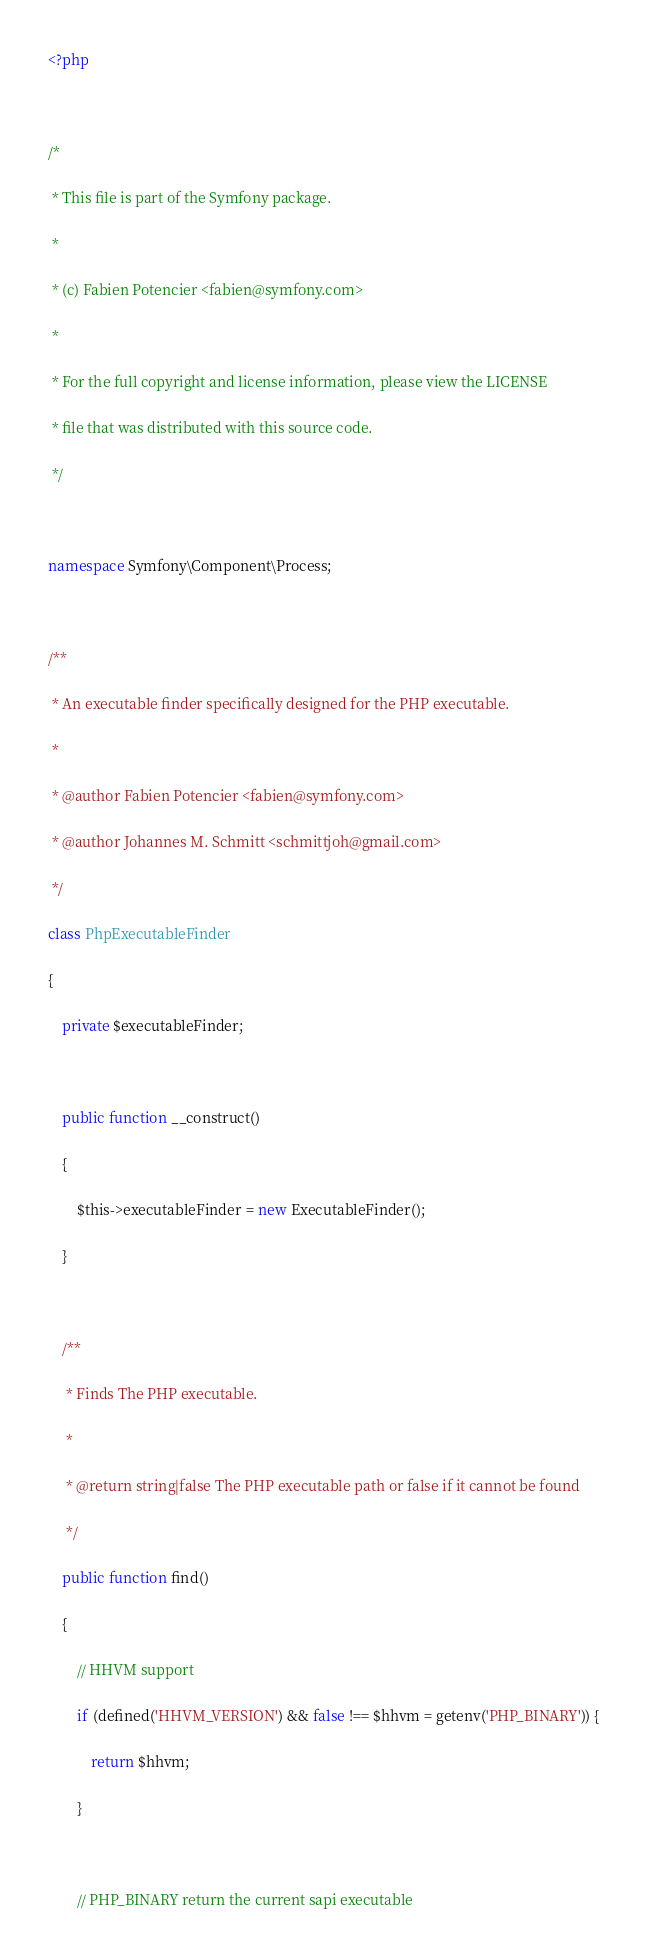<code> <loc_0><loc_0><loc_500><loc_500><_PHP_><?php

/*
 * This file is part of the Symfony package.
 *
 * (c) Fabien Potencier <fabien@symfony.com>
 *
 * For the full copyright and license information, please view the LICENSE
 * file that was distributed with this source code.
 */

namespace Symfony\Component\Process;

/**
 * An executable finder specifically designed for the PHP executable.
 *
 * @author Fabien Potencier <fabien@symfony.com>
 * @author Johannes M. Schmitt <schmittjoh@gmail.com>
 */
class PhpExecutableFinder
{
    private $executableFinder;

    public function __construct()
    {
        $this->executableFinder = new ExecutableFinder();
    }

    /**
     * Finds The PHP executable.
     *
     * @return string|false The PHP executable path or false if it cannot be found
     */
    public function find()
    {
        // HHVM support
        if (defined('HHVM_VERSION') && false !== $hhvm = getenv('PHP_BINARY')) {
            return $hhvm;
        }

        // PHP_BINARY return the current sapi executable</code> 